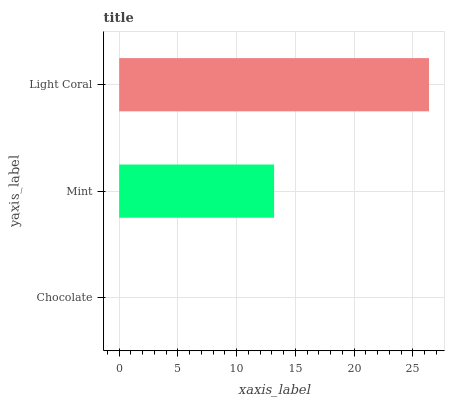Is Chocolate the minimum?
Answer yes or no. Yes. Is Light Coral the maximum?
Answer yes or no. Yes. Is Mint the minimum?
Answer yes or no. No. Is Mint the maximum?
Answer yes or no. No. Is Mint greater than Chocolate?
Answer yes or no. Yes. Is Chocolate less than Mint?
Answer yes or no. Yes. Is Chocolate greater than Mint?
Answer yes or no. No. Is Mint less than Chocolate?
Answer yes or no. No. Is Mint the high median?
Answer yes or no. Yes. Is Mint the low median?
Answer yes or no. Yes. Is Chocolate the high median?
Answer yes or no. No. Is Light Coral the low median?
Answer yes or no. No. 